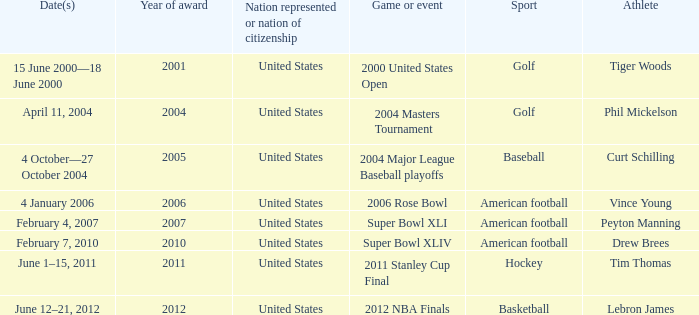In 2011 which sport had the year award? Hockey. Write the full table. {'header': ['Date(s)', 'Year of award', 'Nation represented or nation of citizenship', 'Game or event', 'Sport', 'Athlete'], 'rows': [['15 June 2000—18 June 2000', '2001', 'United States', '2000 United States Open', 'Golf', 'Tiger Woods'], ['April 11, 2004', '2004', 'United States', '2004 Masters Tournament', 'Golf', 'Phil Mickelson'], ['4 October—27 October 2004', '2005', 'United States', '2004 Major League Baseball playoffs', 'Baseball', 'Curt Schilling'], ['4 January 2006', '2006', 'United States', '2006 Rose Bowl', 'American football', 'Vince Young'], ['February 4, 2007', '2007', 'United States', 'Super Bowl XLI', 'American football', 'Peyton Manning'], ['February 7, 2010', '2010', 'United States', 'Super Bowl XLIV', 'American football', 'Drew Brees'], ['June 1–15, 2011', '2011', 'United States', '2011 Stanley Cup Final', 'Hockey', 'Tim Thomas'], ['June 12–21, 2012', '2012', 'United States', '2012 NBA Finals', 'Basketball', 'Lebron James']]} 